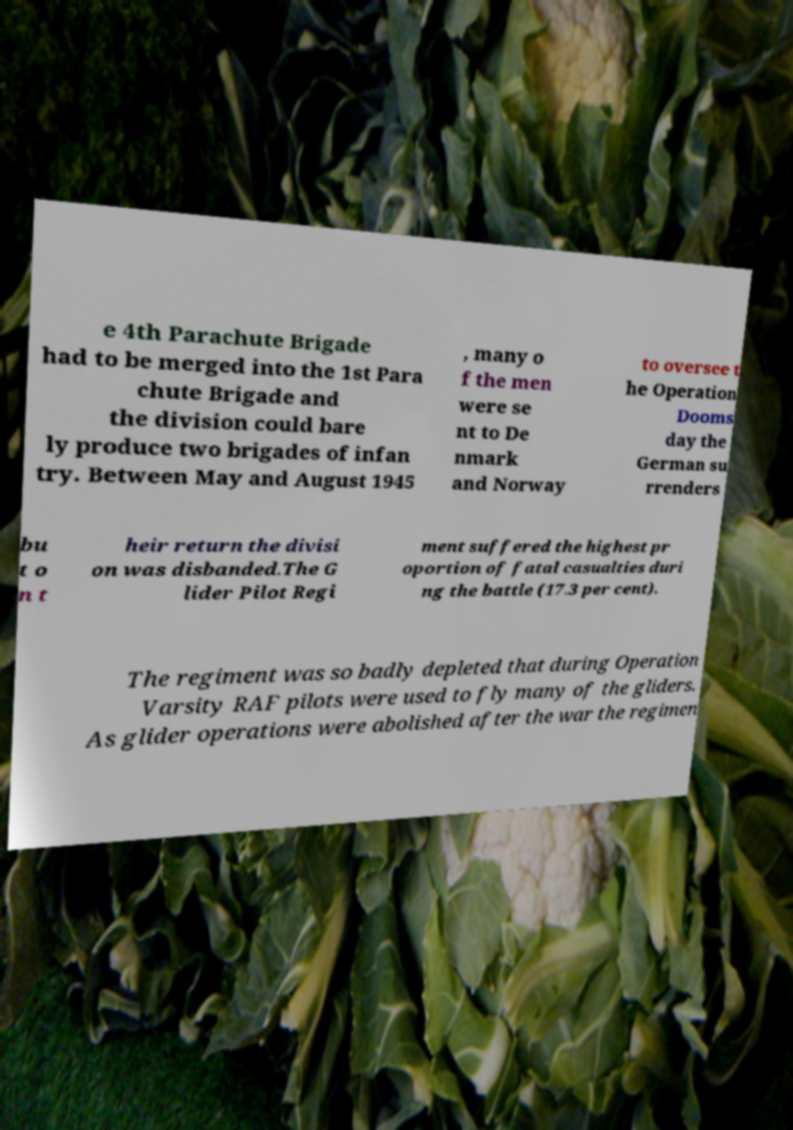There's text embedded in this image that I need extracted. Can you transcribe it verbatim? e 4th Parachute Brigade had to be merged into the 1st Para chute Brigade and the division could bare ly produce two brigades of infan try. Between May and August 1945 , many o f the men were se nt to De nmark and Norway to oversee t he Operation Dooms day the German su rrenders bu t o n t heir return the divisi on was disbanded.The G lider Pilot Regi ment suffered the highest pr oportion of fatal casualties duri ng the battle (17.3 per cent). The regiment was so badly depleted that during Operation Varsity RAF pilots were used to fly many of the gliders. As glider operations were abolished after the war the regimen 